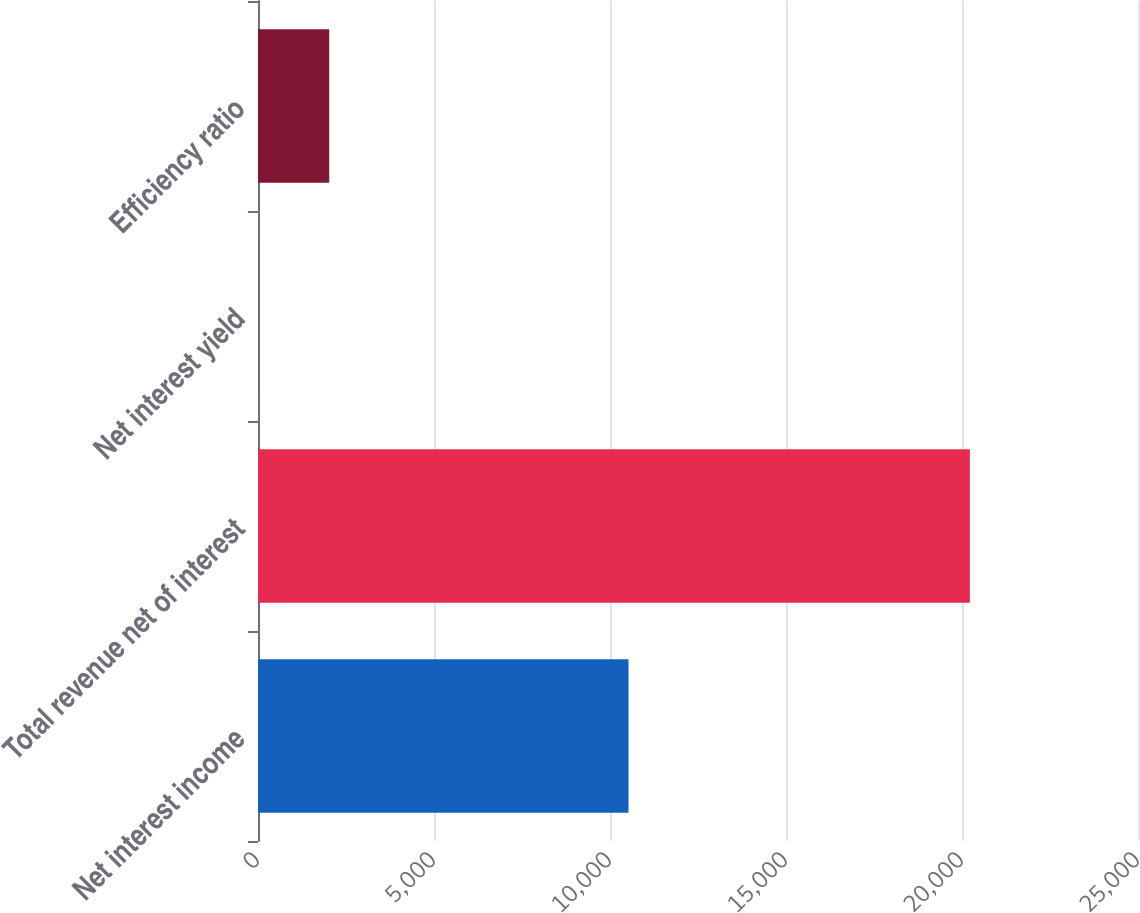Convert chart to OTSL. <chart><loc_0><loc_0><loc_500><loc_500><bar_chart><fcel>Net interest income<fcel>Total revenue net of interest<fcel>Net interest yield<fcel>Efficiency ratio<nl><fcel>10526<fcel>20224<fcel>2.23<fcel>2024.41<nl></chart> 